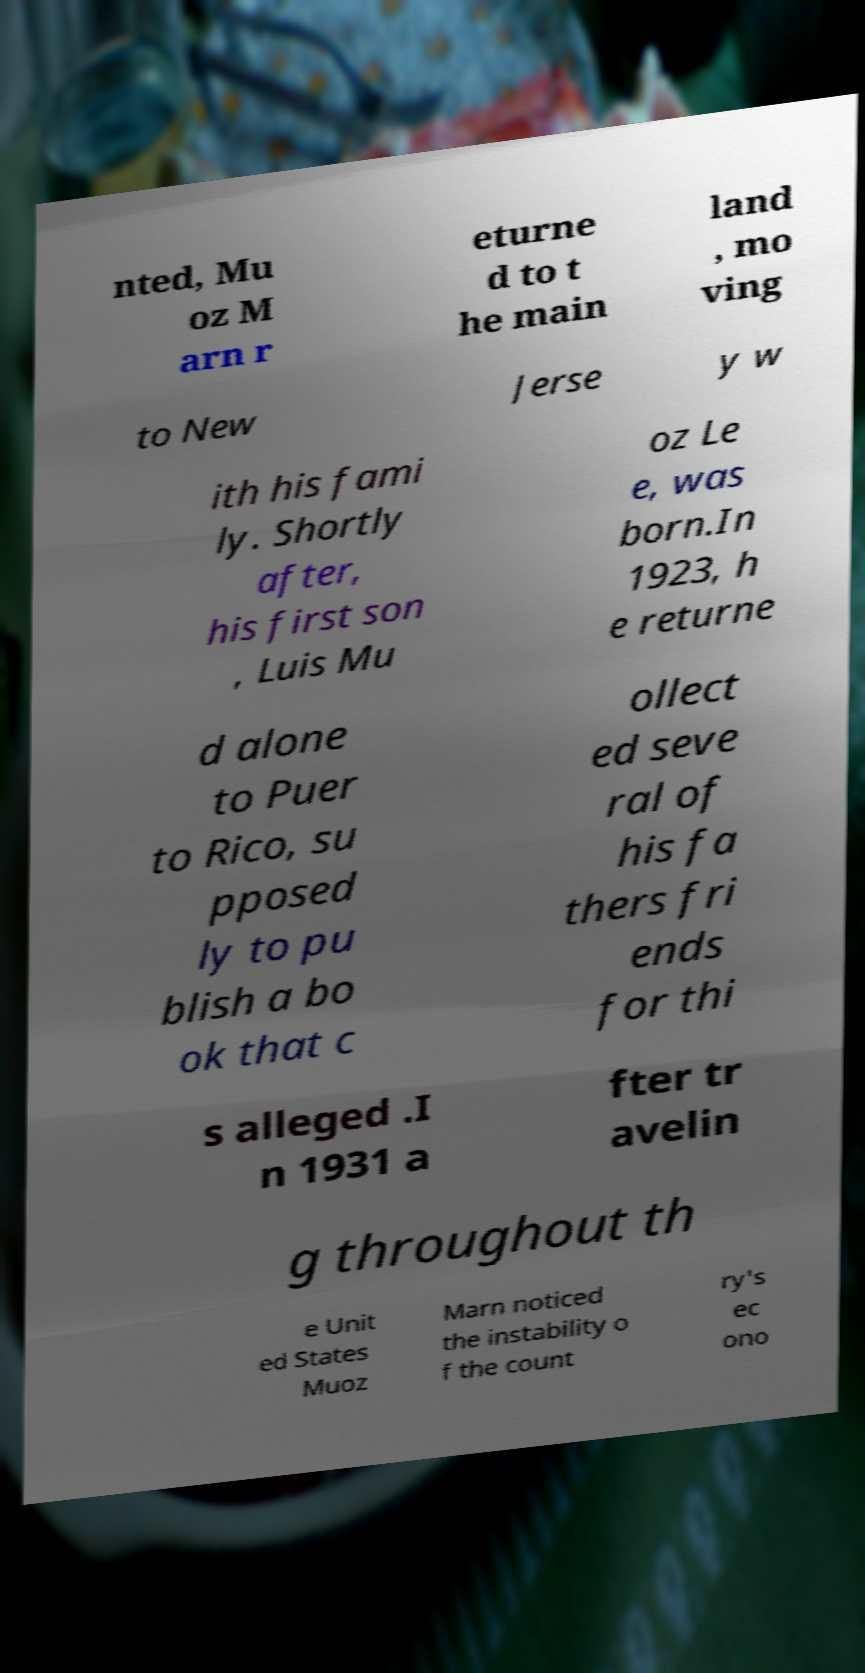Could you assist in decoding the text presented in this image and type it out clearly? nted, Mu oz M arn r eturne d to t he main land , mo ving to New Jerse y w ith his fami ly. Shortly after, his first son , Luis Mu oz Le e, was born.In 1923, h e returne d alone to Puer to Rico, su pposed ly to pu blish a bo ok that c ollect ed seve ral of his fa thers fri ends for thi s alleged .I n 1931 a fter tr avelin g throughout th e Unit ed States Muoz Marn noticed the instability o f the count ry's ec ono 